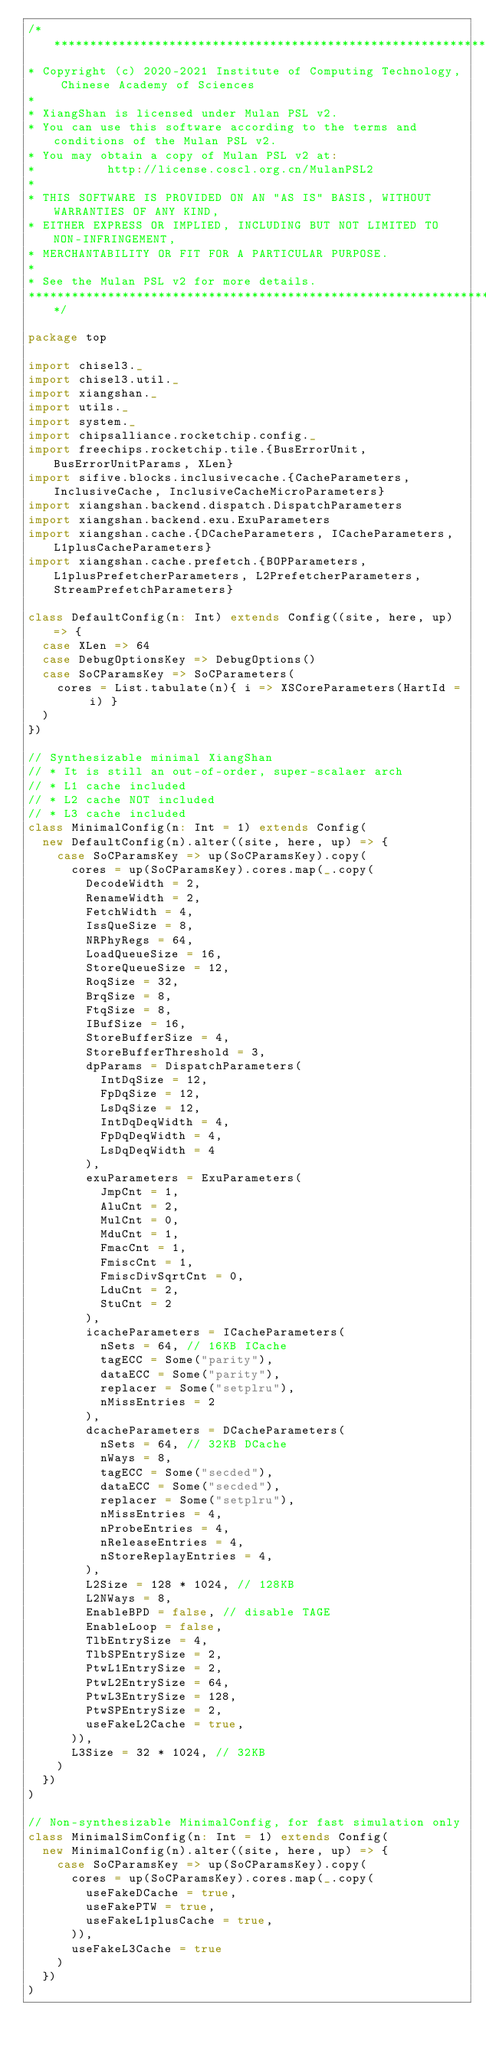Convert code to text. <code><loc_0><loc_0><loc_500><loc_500><_Scala_>/***************************************************************************************
* Copyright (c) 2020-2021 Institute of Computing Technology, Chinese Academy of Sciences
*
* XiangShan is licensed under Mulan PSL v2.
* You can use this software according to the terms and conditions of the Mulan PSL v2.
* You may obtain a copy of Mulan PSL v2 at:
*          http://license.coscl.org.cn/MulanPSL2
*
* THIS SOFTWARE IS PROVIDED ON AN "AS IS" BASIS, WITHOUT WARRANTIES OF ANY KIND,
* EITHER EXPRESS OR IMPLIED, INCLUDING BUT NOT LIMITED TO NON-INFRINGEMENT,
* MERCHANTABILITY OR FIT FOR A PARTICULAR PURPOSE.
*
* See the Mulan PSL v2 for more details.
***************************************************************************************/

package top

import chisel3._
import chisel3.util._
import xiangshan._
import utils._
import system._
import chipsalliance.rocketchip.config._
import freechips.rocketchip.tile.{BusErrorUnit, BusErrorUnitParams, XLen}
import sifive.blocks.inclusivecache.{CacheParameters, InclusiveCache, InclusiveCacheMicroParameters}
import xiangshan.backend.dispatch.DispatchParameters
import xiangshan.backend.exu.ExuParameters
import xiangshan.cache.{DCacheParameters, ICacheParameters, L1plusCacheParameters}
import xiangshan.cache.prefetch.{BOPParameters, L1plusPrefetcherParameters, L2PrefetcherParameters, StreamPrefetchParameters}

class DefaultConfig(n: Int) extends Config((site, here, up) => {
  case XLen => 64
  case DebugOptionsKey => DebugOptions()
  case SoCParamsKey => SoCParameters(
    cores = List.tabulate(n){ i => XSCoreParameters(HartId = i) }
  )
})

// Synthesizable minimal XiangShan
// * It is still an out-of-order, super-scalaer arch
// * L1 cache included
// * L2 cache NOT included
// * L3 cache included
class MinimalConfig(n: Int = 1) extends Config(
  new DefaultConfig(n).alter((site, here, up) => {
    case SoCParamsKey => up(SoCParamsKey).copy(
      cores = up(SoCParamsKey).cores.map(_.copy(
        DecodeWidth = 2,
        RenameWidth = 2,
        FetchWidth = 4,
        IssQueSize = 8,
        NRPhyRegs = 64,
        LoadQueueSize = 16,
        StoreQueueSize = 12,
        RoqSize = 32,
        BrqSize = 8,
        FtqSize = 8,
        IBufSize = 16,
        StoreBufferSize = 4,
        StoreBufferThreshold = 3,
        dpParams = DispatchParameters(
          IntDqSize = 12,
          FpDqSize = 12,
          LsDqSize = 12,
          IntDqDeqWidth = 4,
          FpDqDeqWidth = 4,
          LsDqDeqWidth = 4
        ),
        exuParameters = ExuParameters(
          JmpCnt = 1,
          AluCnt = 2,
          MulCnt = 0,
          MduCnt = 1,
          FmacCnt = 1,
          FmiscCnt = 1,
          FmiscDivSqrtCnt = 0,
          LduCnt = 2,
          StuCnt = 2
        ),
        icacheParameters = ICacheParameters(
          nSets = 64, // 16KB ICache
          tagECC = Some("parity"),
          dataECC = Some("parity"),
          replacer = Some("setplru"),
          nMissEntries = 2
        ),
        dcacheParameters = DCacheParameters(
          nSets = 64, // 32KB DCache
          nWays = 8,
          tagECC = Some("secded"),
          dataECC = Some("secded"),
          replacer = Some("setplru"),
          nMissEntries = 4,
          nProbeEntries = 4,
          nReleaseEntries = 4,
          nStoreReplayEntries = 4,
        ),
        L2Size = 128 * 1024, // 128KB
        L2NWays = 8,
        EnableBPD = false, // disable TAGE
        EnableLoop = false,
        TlbEntrySize = 4,
        TlbSPEntrySize = 2,
        PtwL1EntrySize = 2,
        PtwL2EntrySize = 64,
        PtwL3EntrySize = 128,
        PtwSPEntrySize = 2,
        useFakeL2Cache = true,
      )),
      L3Size = 32 * 1024, // 32KB
    )
  })
)

// Non-synthesizable MinimalConfig, for fast simulation only
class MinimalSimConfig(n: Int = 1) extends Config(
  new MinimalConfig(n).alter((site, here, up) => {
    case SoCParamsKey => up(SoCParamsKey).copy(
      cores = up(SoCParamsKey).cores.map(_.copy(
        useFakeDCache = true,
        useFakePTW = true,
        useFakeL1plusCache = true,
      )),
      useFakeL3Cache = true
    )
  })
)
</code> 